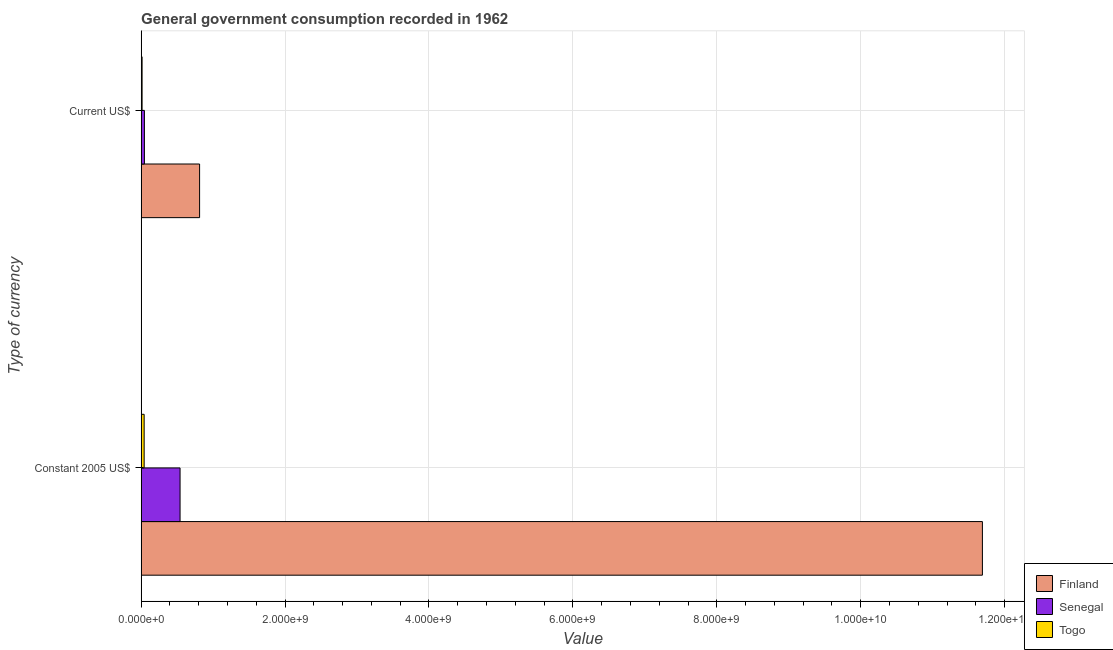How many different coloured bars are there?
Your answer should be very brief. 3. Are the number of bars per tick equal to the number of legend labels?
Give a very brief answer. Yes. Are the number of bars on each tick of the Y-axis equal?
Your answer should be compact. Yes. What is the label of the 2nd group of bars from the top?
Make the answer very short. Constant 2005 US$. What is the value consumed in current us$ in Togo?
Provide a short and direct response. 1.31e+07. Across all countries, what is the maximum value consumed in constant 2005 us$?
Provide a short and direct response. 1.17e+1. Across all countries, what is the minimum value consumed in constant 2005 us$?
Provide a short and direct response. 4.18e+07. In which country was the value consumed in current us$ minimum?
Your response must be concise. Togo. What is the total value consumed in constant 2005 us$ in the graph?
Ensure brevity in your answer.  1.23e+1. What is the difference between the value consumed in current us$ in Senegal and that in Finland?
Your answer should be very brief. -7.67e+08. What is the difference between the value consumed in current us$ in Finland and the value consumed in constant 2005 us$ in Togo?
Make the answer very short. 7.70e+08. What is the average value consumed in constant 2005 us$ per country?
Offer a terse response. 4.09e+09. What is the difference between the value consumed in current us$ and value consumed in constant 2005 us$ in Togo?
Make the answer very short. -2.87e+07. What is the ratio of the value consumed in current us$ in Senegal to that in Togo?
Offer a terse response. 3.48. Is the value consumed in constant 2005 us$ in Finland less than that in Senegal?
Make the answer very short. No. In how many countries, is the value consumed in current us$ greater than the average value consumed in current us$ taken over all countries?
Your answer should be very brief. 1. What does the 1st bar from the top in Constant 2005 US$ represents?
Your response must be concise. Togo. What does the 2nd bar from the bottom in Constant 2005 US$ represents?
Provide a succinct answer. Senegal. How many bars are there?
Ensure brevity in your answer.  6. How many countries are there in the graph?
Keep it short and to the point. 3. What is the difference between two consecutive major ticks on the X-axis?
Give a very brief answer. 2.00e+09. Are the values on the major ticks of X-axis written in scientific E-notation?
Your response must be concise. Yes. How many legend labels are there?
Your answer should be compact. 3. How are the legend labels stacked?
Your answer should be compact. Vertical. What is the title of the graph?
Keep it short and to the point. General government consumption recorded in 1962. What is the label or title of the X-axis?
Ensure brevity in your answer.  Value. What is the label or title of the Y-axis?
Make the answer very short. Type of currency. What is the Value in Finland in Constant 2005 US$?
Make the answer very short. 1.17e+1. What is the Value in Senegal in Constant 2005 US$?
Make the answer very short. 5.41e+08. What is the Value in Togo in Constant 2005 US$?
Give a very brief answer. 4.18e+07. What is the Value of Finland in Current US$?
Offer a very short reply. 8.12e+08. What is the Value in Senegal in Current US$?
Ensure brevity in your answer.  4.55e+07. What is the Value of Togo in Current US$?
Keep it short and to the point. 1.31e+07. Across all Type of currency, what is the maximum Value in Finland?
Ensure brevity in your answer.  1.17e+1. Across all Type of currency, what is the maximum Value of Senegal?
Give a very brief answer. 5.41e+08. Across all Type of currency, what is the maximum Value in Togo?
Your answer should be very brief. 4.18e+07. Across all Type of currency, what is the minimum Value of Finland?
Offer a terse response. 8.12e+08. Across all Type of currency, what is the minimum Value of Senegal?
Your answer should be very brief. 4.55e+07. Across all Type of currency, what is the minimum Value of Togo?
Keep it short and to the point. 1.31e+07. What is the total Value in Finland in the graph?
Your answer should be very brief. 1.25e+1. What is the total Value of Senegal in the graph?
Ensure brevity in your answer.  5.86e+08. What is the total Value of Togo in the graph?
Your answer should be very brief. 5.48e+07. What is the difference between the Value of Finland in Constant 2005 US$ and that in Current US$?
Provide a succinct answer. 1.09e+1. What is the difference between the Value in Senegal in Constant 2005 US$ and that in Current US$?
Your answer should be compact. 4.95e+08. What is the difference between the Value of Togo in Constant 2005 US$ and that in Current US$?
Offer a terse response. 2.87e+07. What is the difference between the Value in Finland in Constant 2005 US$ and the Value in Senegal in Current US$?
Make the answer very short. 1.16e+1. What is the difference between the Value of Finland in Constant 2005 US$ and the Value of Togo in Current US$?
Make the answer very short. 1.17e+1. What is the difference between the Value in Senegal in Constant 2005 US$ and the Value in Togo in Current US$?
Ensure brevity in your answer.  5.28e+08. What is the average Value of Finland per Type of currency?
Provide a short and direct response. 6.25e+09. What is the average Value in Senegal per Type of currency?
Make the answer very short. 2.93e+08. What is the average Value in Togo per Type of currency?
Keep it short and to the point. 2.74e+07. What is the difference between the Value of Finland and Value of Senegal in Constant 2005 US$?
Give a very brief answer. 1.12e+1. What is the difference between the Value of Finland and Value of Togo in Constant 2005 US$?
Offer a terse response. 1.16e+1. What is the difference between the Value in Senegal and Value in Togo in Constant 2005 US$?
Your answer should be compact. 4.99e+08. What is the difference between the Value of Finland and Value of Senegal in Current US$?
Give a very brief answer. 7.67e+08. What is the difference between the Value of Finland and Value of Togo in Current US$?
Your answer should be compact. 7.99e+08. What is the difference between the Value in Senegal and Value in Togo in Current US$?
Your answer should be very brief. 3.24e+07. What is the ratio of the Value of Finland in Constant 2005 US$ to that in Current US$?
Provide a short and direct response. 14.4. What is the ratio of the Value of Senegal in Constant 2005 US$ to that in Current US$?
Provide a short and direct response. 11.9. What is the ratio of the Value of Togo in Constant 2005 US$ to that in Current US$?
Your answer should be very brief. 3.19. What is the difference between the highest and the second highest Value of Finland?
Ensure brevity in your answer.  1.09e+1. What is the difference between the highest and the second highest Value in Senegal?
Your answer should be very brief. 4.95e+08. What is the difference between the highest and the second highest Value of Togo?
Provide a short and direct response. 2.87e+07. What is the difference between the highest and the lowest Value of Finland?
Give a very brief answer. 1.09e+1. What is the difference between the highest and the lowest Value of Senegal?
Offer a very short reply. 4.95e+08. What is the difference between the highest and the lowest Value of Togo?
Your response must be concise. 2.87e+07. 